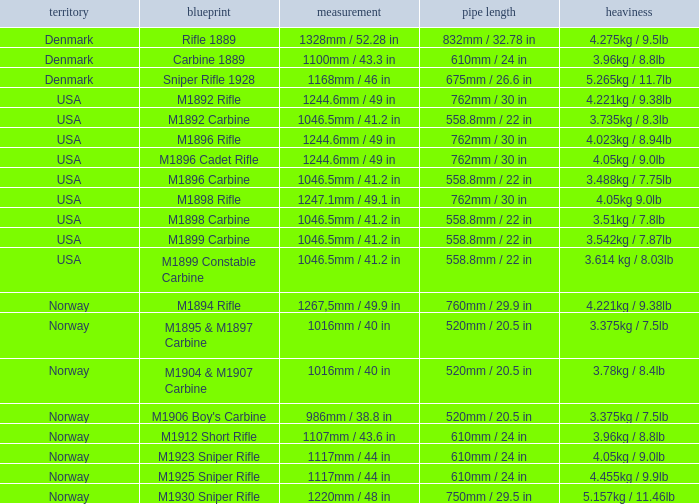What is Length, when Barrel Length is 750mm / 29.5 in? 1220mm / 48 in. 